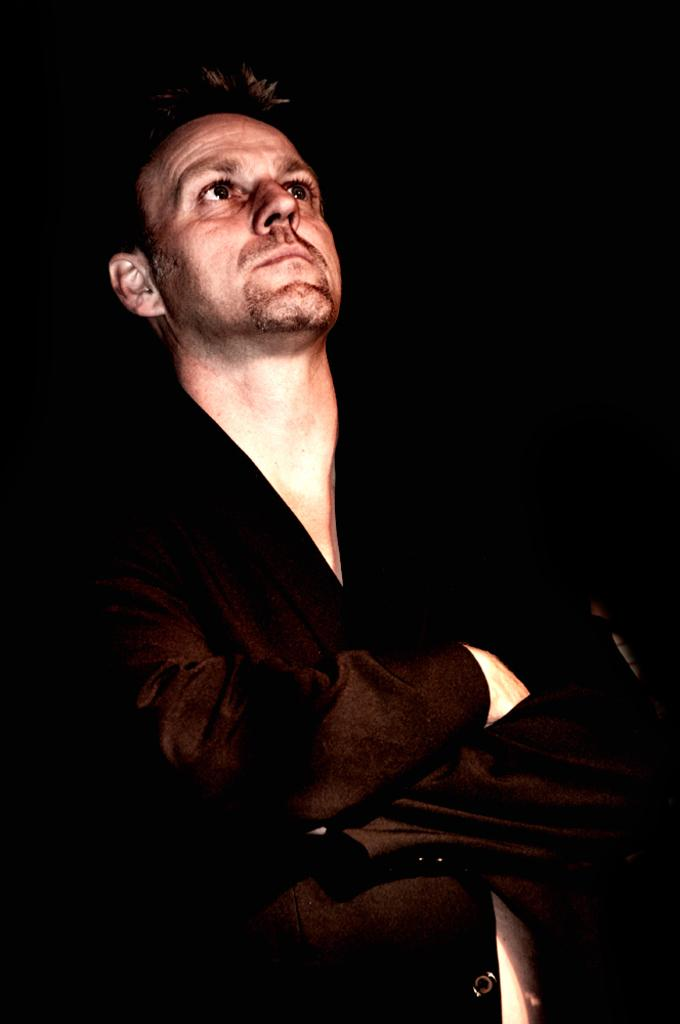What is the main subject in the foreground of the image? There is a person in the foreground of the image. What is the color of the background in the image? The background of the image is black in color. What type of breakfast is the person eating in the image? There is no indication in the image that the person is eating breakfast, so it cannot be determined from the picture. 